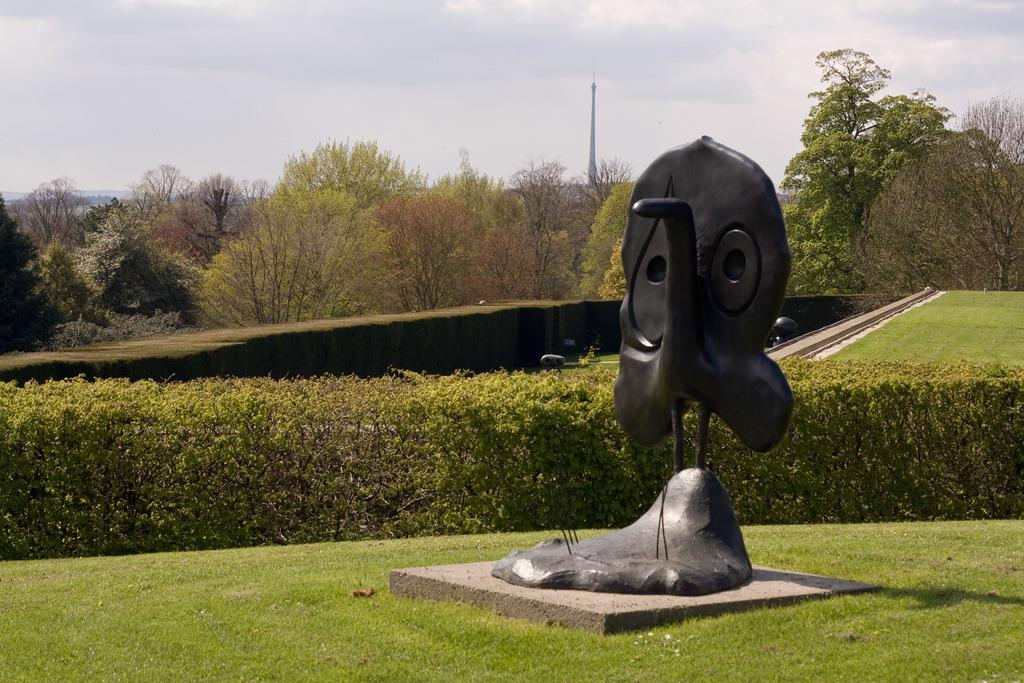What can be found on the path in the image? There is a statue on the path in the image. What is located behind the statue? There is a hedge and trees behind the statue. What else can be seen in the image? There are poles visible in the image. What is visible in the background of the image? The sky is visible in the image. What objects are present on the path? There are objects on the path in the image. What type of pen is being used to write on the statue in the image? There is no pen or writing present on the statue in the image. How many slaves are visible in the image? There are no slaves present in the image. 